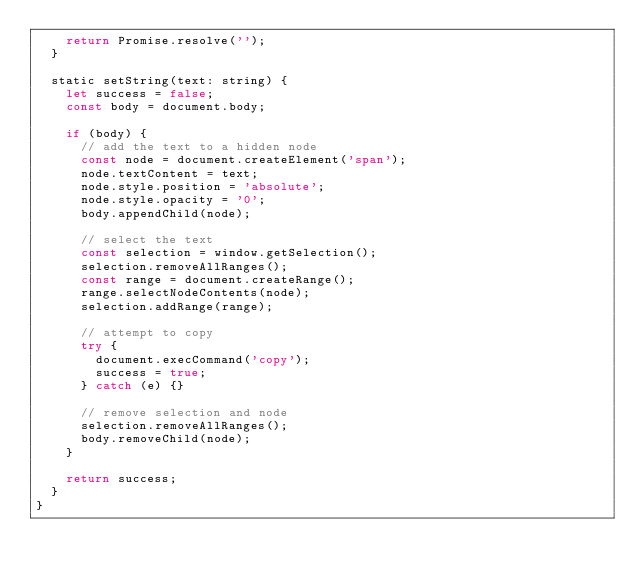<code> <loc_0><loc_0><loc_500><loc_500><_JavaScript_>    return Promise.resolve('');
  }

  static setString(text: string) {
    let success = false;
    const body = document.body;

    if (body) {
      // add the text to a hidden node
      const node = document.createElement('span');
      node.textContent = text;
      node.style.position = 'absolute';
      node.style.opacity = '0';
      body.appendChild(node);

      // select the text
      const selection = window.getSelection();
      selection.removeAllRanges();
      const range = document.createRange();
      range.selectNodeContents(node);
      selection.addRange(range);

      // attempt to copy
      try {
        document.execCommand('copy');
        success = true;
      } catch (e) {}

      // remove selection and node
      selection.removeAllRanges();
      body.removeChild(node);
    }

    return success;
  }
}
</code> 